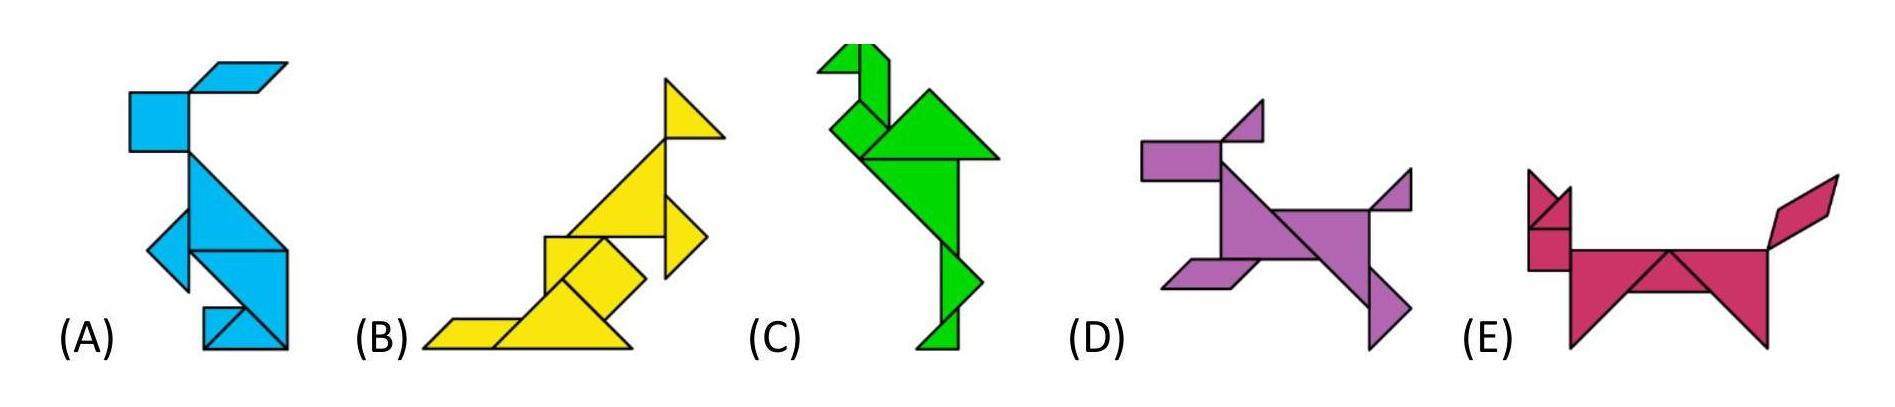These five animals are made up from different shapes. There is one shape which is only used on one animal. On which animal is this shape used?
Choices: ['A', 'B', 'C', 'D', 'E'] Answer is D. 